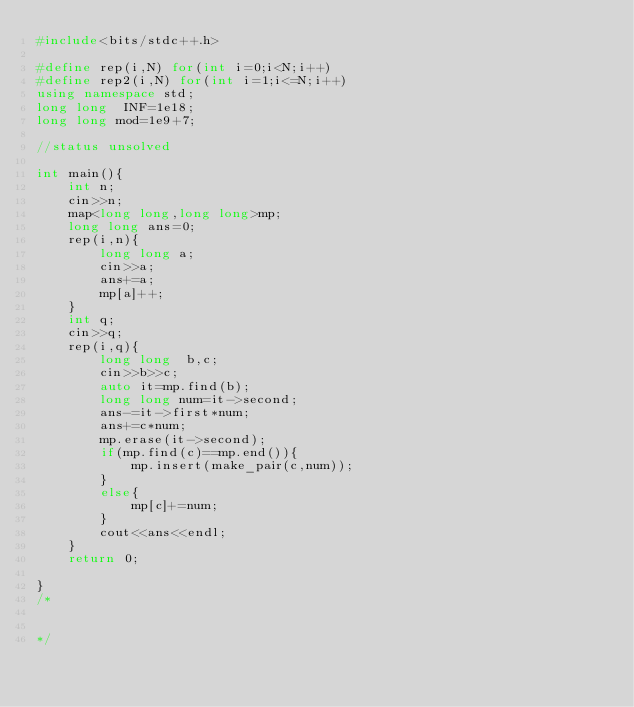Convert code to text. <code><loc_0><loc_0><loc_500><loc_500><_C++_>#include<bits/stdc++.h>

#define rep(i,N) for(int i=0;i<N;i++)
#define rep2(i,N) for(int i=1;i<=N;i++)
using namespace std;
long long  INF=1e18;
long long mod=1e9+7;

//status unsolved

int main(){
    int n;
    cin>>n;
    map<long long,long long>mp;
    long long ans=0;
    rep(i,n){
        long long a;
        cin>>a;
        ans+=a;
        mp[a]++;
    }
    int q;
    cin>>q;
    rep(i,q){
        long long  b,c;
        cin>>b>>c;
        auto it=mp.find(b);
        long long num=it->second;
        ans-=it->first*num;
        ans+=c*num;
        mp.erase(it->second);
        if(mp.find(c)==mp.end()){
            mp.insert(make_pair(c,num));
        }
        else{
            mp[c]+=num;
        }
        cout<<ans<<endl;
    }
    return 0;

}
/*


*/
</code> 